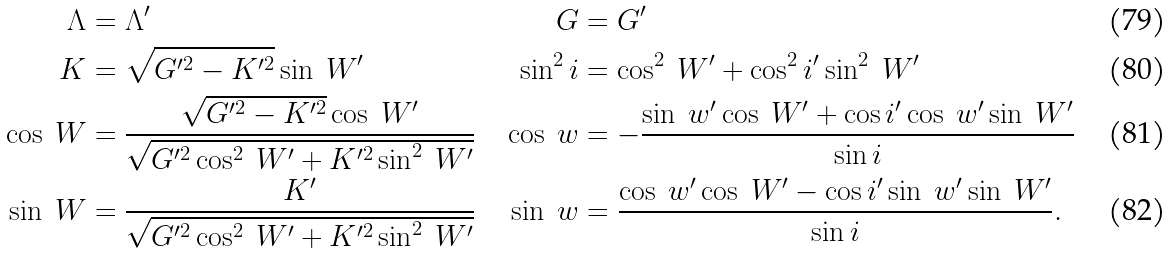<formula> <loc_0><loc_0><loc_500><loc_500>\Lambda & = \Lambda ^ { \prime } & G & = G ^ { \prime } \\ K & = \sqrt { G ^ { \prime 2 } - K ^ { \prime 2 } } \sin \ W ^ { \prime } & \sin ^ { 2 } i & = \cos ^ { 2 } \ W ^ { \prime } + \cos ^ { 2 } i ^ { \prime } \sin ^ { 2 } \ W ^ { \prime } \\ \cos \ W & = \frac { \sqrt { G ^ { \prime 2 } - K ^ { \prime 2 } } \cos \ W ^ { \prime } } { \sqrt { G ^ { \prime 2 } \cos ^ { 2 } \ W ^ { \prime } + K ^ { \prime 2 } \sin ^ { 2 } \ W ^ { \prime } } } & \cos \ w & = - \frac { \sin \ w ^ { \prime } \cos \ W ^ { \prime } + \cos i ^ { \prime } \cos \ w ^ { \prime } \sin \ W ^ { \prime } } { \sin i } \\ \sin \ W & = \frac { K ^ { \prime } } { \sqrt { G ^ { \prime 2 } \cos ^ { 2 } \ W ^ { \prime } + K ^ { \prime 2 } \sin ^ { 2 } \ W ^ { \prime } } } & \sin \ w & = \frac { \cos \ w ^ { \prime } \cos \ W ^ { \prime } - \cos i ^ { \prime } \sin \ w ^ { \prime } \sin \ W ^ { \prime } } { \sin i } .</formula> 